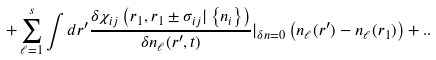<formula> <loc_0><loc_0><loc_500><loc_500>+ \sum _ { \ell = 1 } ^ { s } \int d r ^ { \prime } \frac { \delta \chi _ { i j } \left ( r _ { 1 } , r _ { 1 } \pm { \sigma } _ { i j } | \left \{ n _ { i } \right \} \right ) } { \delta n _ { \ell } ( r ^ { \prime } , t ) } | _ { \delta n = 0 } \left ( n _ { \ell } ( r ^ { \prime } ) - n _ { \ell } ( r _ { 1 } ) \right ) + . . \\</formula> 